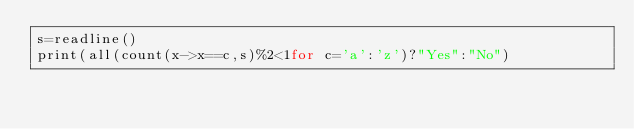<code> <loc_0><loc_0><loc_500><loc_500><_Julia_>s=readline()
print(all(count(x->x==c,s)%2<1for c='a':'z')?"Yes":"No")</code> 